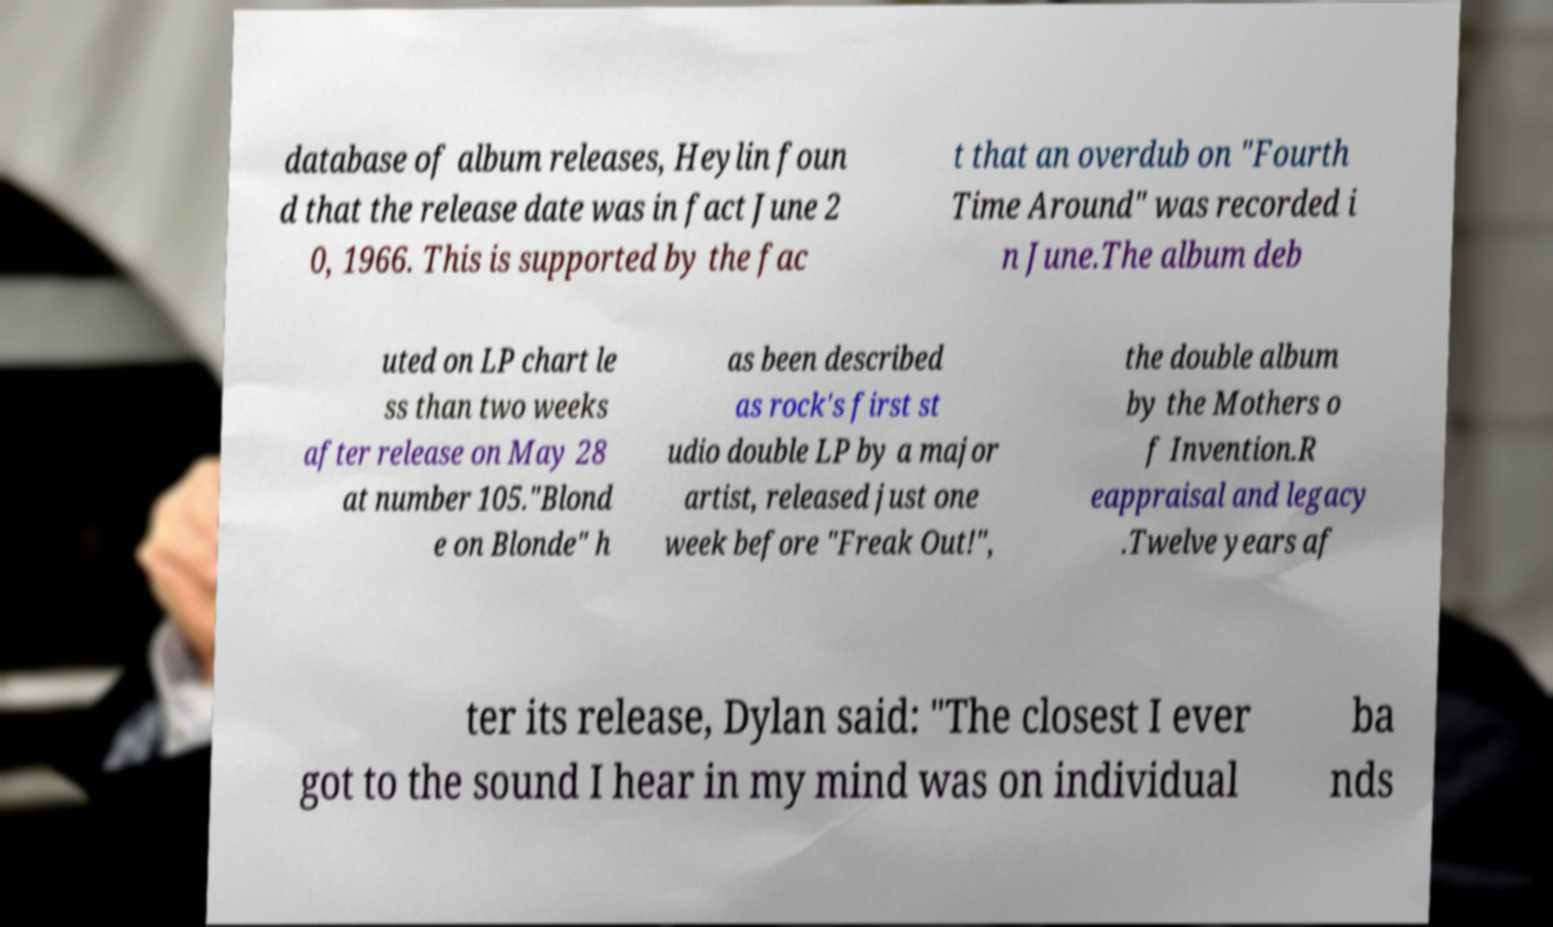Please identify and transcribe the text found in this image. database of album releases, Heylin foun d that the release date was in fact June 2 0, 1966. This is supported by the fac t that an overdub on "Fourth Time Around" was recorded i n June.The album deb uted on LP chart le ss than two weeks after release on May 28 at number 105."Blond e on Blonde" h as been described as rock's first st udio double LP by a major artist, released just one week before "Freak Out!", the double album by the Mothers o f Invention.R eappraisal and legacy .Twelve years af ter its release, Dylan said: "The closest I ever got to the sound I hear in my mind was on individual ba nds 